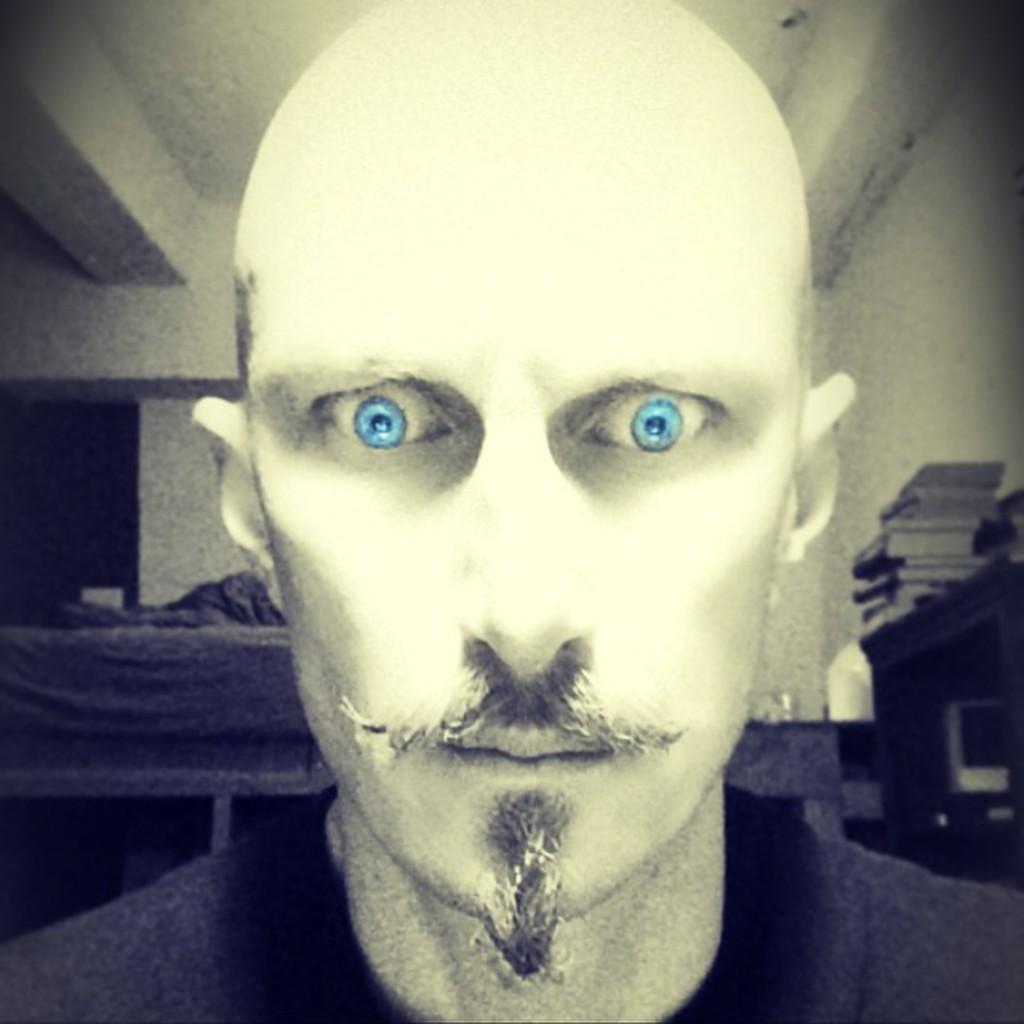How would you summarize this image in a sentence or two? In the image there is a man standing, this is a black and white picture, he had blue eyes and bald head, on the right side there are some books on a table on background. 